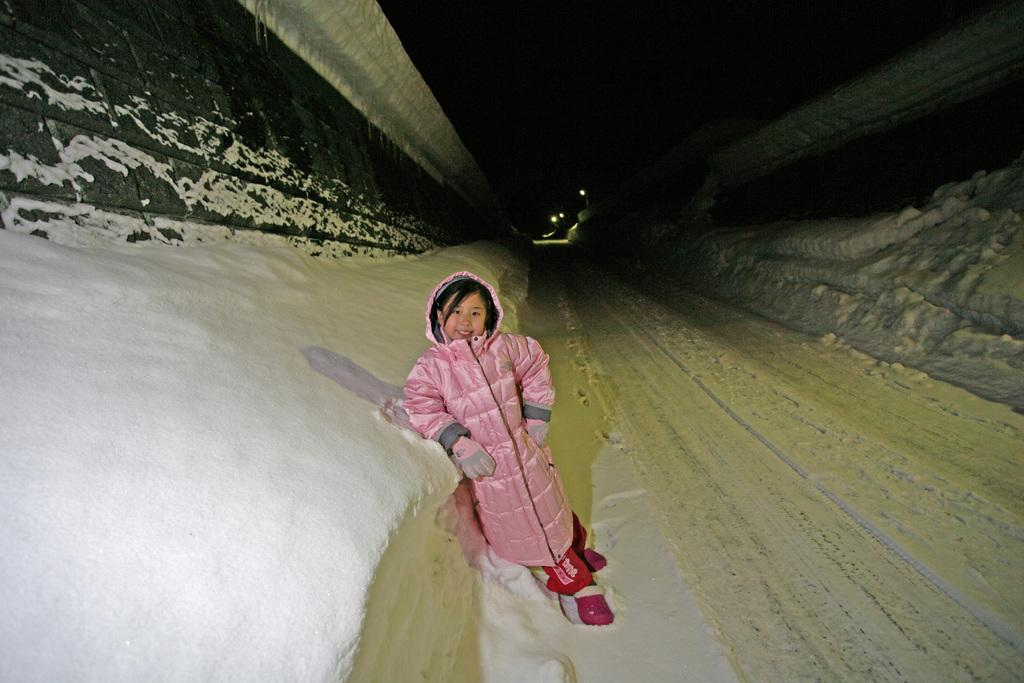What is the child doing in the image? The child is standing on the ground in the image. What is covering the ground in the image? The ground is covered with snow. What type of wall can be seen in the image? There is a wall with stones in the image. What structure is visible above the wall in the image? There is a roof visible in the image. What might be used for illumination in the image? There are lights present in the image. What songs is the writer composing on the shelf in the image? There is no writer, songs, or shelf present in the image. 